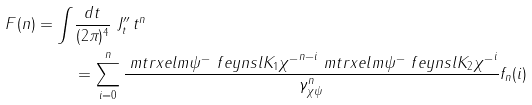Convert formula to latex. <formula><loc_0><loc_0><loc_500><loc_500>F ( n ) = \int & \frac { d t } { ( 2 \pi ) ^ { 4 } } \ J ^ { \prime \prime } _ { t } \, t ^ { n } \\ & = \sum _ { i = 0 } ^ { n } \frac { \ m t r x e l m { \psi ^ { - } } { \ f e y n s l { K } _ { 1 } } { \chi ^ { - } } ^ { n - i } \ m t r x e l m { \psi ^ { - } } { \ f e y n s l { K } _ { 2 } } { \chi ^ { - } } ^ { i } } { \gamma ^ { n } _ { \chi \psi } } f _ { n } ( i )</formula> 